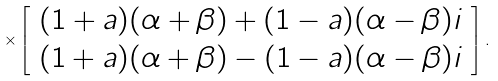<formula> <loc_0><loc_0><loc_500><loc_500>\times \left [ \begin{array} { c } ( 1 + a ) ( \alpha + \beta ) + ( 1 - a ) ( \alpha - \beta ) i \\ ( 1 + a ) ( \alpha + \beta ) - ( 1 - a ) ( \alpha - \beta ) i \end{array} \right ] .</formula> 